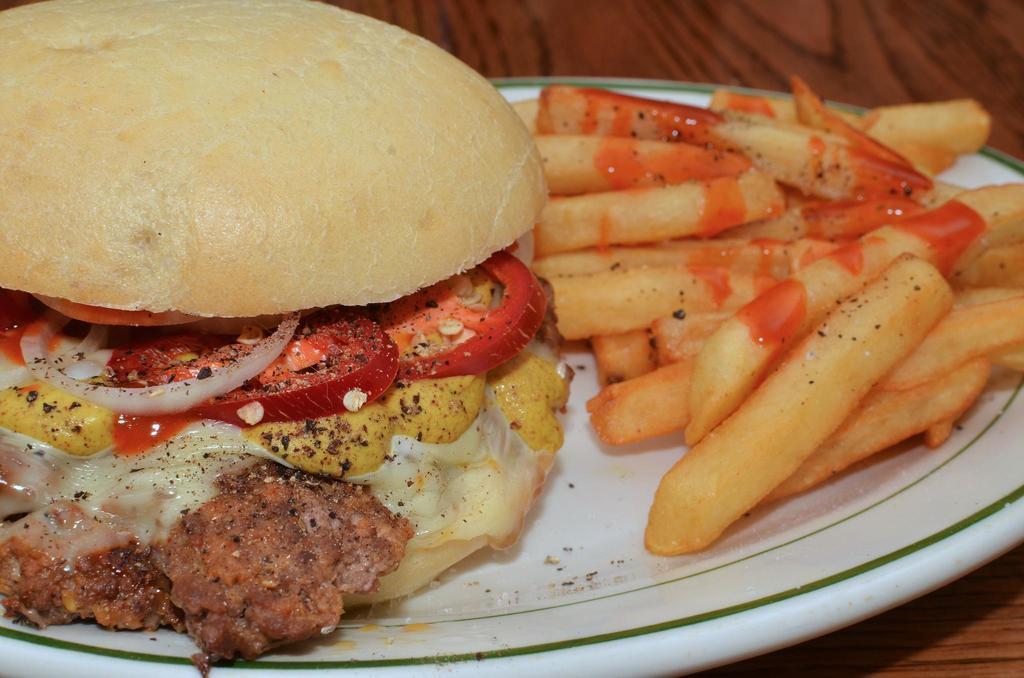Describe this image in one or two sentences. In this image there is a burger and fries on a plate, the plate is on the table. 